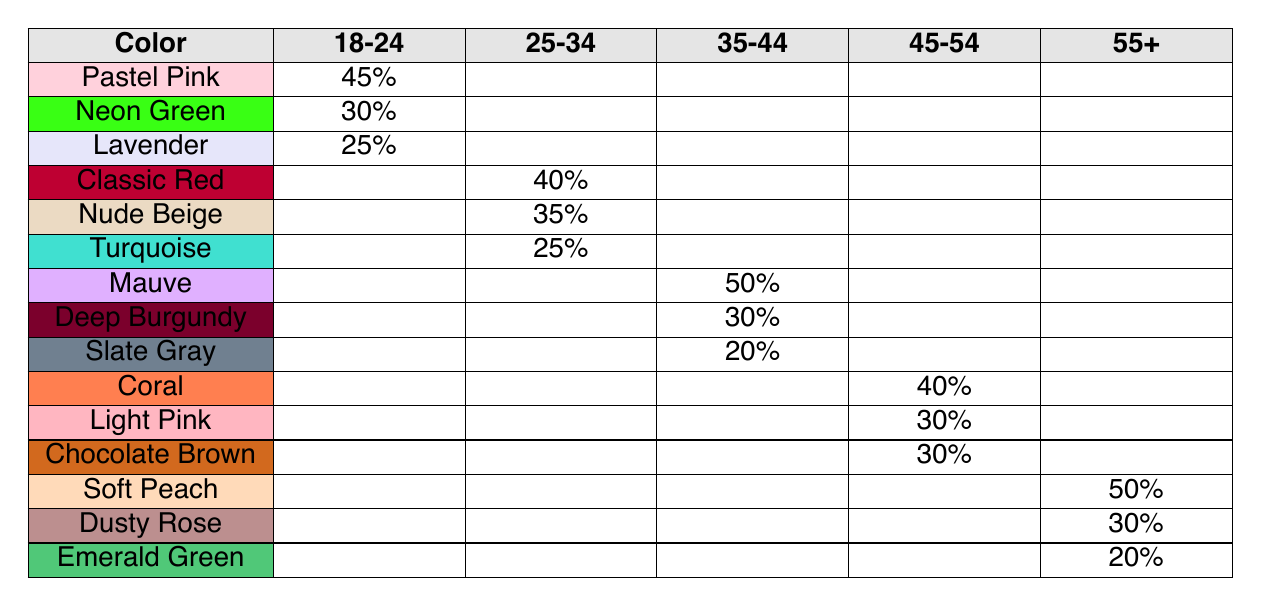What is the most popular nail polish color among the 18-24 age group? From the table, the most popular color in this age group is "Pastel Pink," with a popularity percentage of 45%
Answer: Pastel Pink Which color has the highest popularity in the 45-54 age group? The highest popularity in the 45-54 age group is attributed to "Coral," with a popularity percentage of 40%
Answer: Coral Does the 55 and above age group have a preference for darker colors? The most popular colors in the 55 and above group are "Soft Peach" and "Dusty Rose," neither of which is particularly dark, indicating a preference for lighter shades
Answer: No What is the least popular color overall across all age groups? By examining all age groups, "Slate Gray" in the 35-44 age group has the lowest popularity percentage at 20%
Answer: Slate Gray Calculate the average popularity percentage of the preferred colors for the 25-34 age group. The colors and their popularity percentages are Classic Red (40%), Nude Beige (35%), and Turquoise (25%). The average is calculated as (40 + 35 + 25) / 3 = 100 / 3 = 33.33%
Answer: 33.33% Which age group has the highest overall maximum popularity value among its colors? The 35-44 age group has a maximum popularity percentage of 50% for "Mauve," which is higher than the maximum values of other groups, notably 45%, 40%, and 50% in the respective groups
Answer: 35-44 age group How many colors have a popularity percentage of 30% or higher in the 25-34 age group? The 25-34 age group has two colors (Classic Red at 40% and Nude Beige at 35%) that meet the 30% threshold, totaling two colors
Answer: 2 What percentage of the preferred colors for the 55 and above group are lower than 30%? The colors in the 55 and above group include "Soft Peach" (50%), "Dusty Rose" (30%), and "Emerald Green" (20%). "Emerald Green" is lower than 30%, therefore 1 out of 3 colors is below that percentage. This gives a proportion of 1/3 or about 33.33%
Answer: 33.33% 